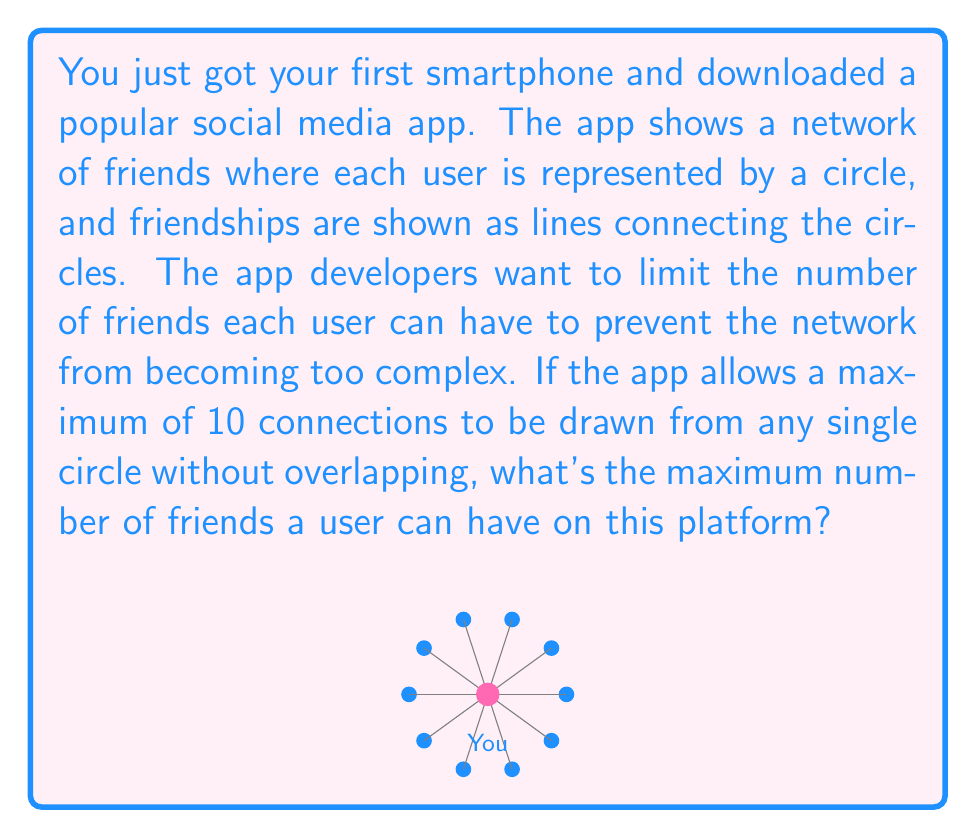Show me your answer to this math problem. Let's approach this step-by-step:

1) In graph theory, this problem is related to the concept of the degree of a vertex in a graph. The degree of a vertex is the number of edges connected to it.

2) In this case, each user is represented by a vertex (circle), and each friendship is represented by an edge (line).

3) The question states that a maximum of 10 connections can be drawn from any single circle without overlapping. This means the maximum degree of any vertex in this graph is 10.

4) However, we need to consider that in a friendship network, connections are bidirectional. If user A is friends with user B, then user B is also friends with user A. This means each edge contributes to the degree of two vertices.

5) Therefore, the maximum number of friends a user can have is equal to the maximum degree of a vertex in this graph.

6) The maximum degree is given as 10, so the maximum number of friends a user can have is also 10.

Mathematically, we can express this as:

$$\text{Max Friends} = \text{Max Degree} = 10$$

This solution ensures that no user's circle in the network visualization will have more than 10 non-overlapping connections.
Answer: 10 